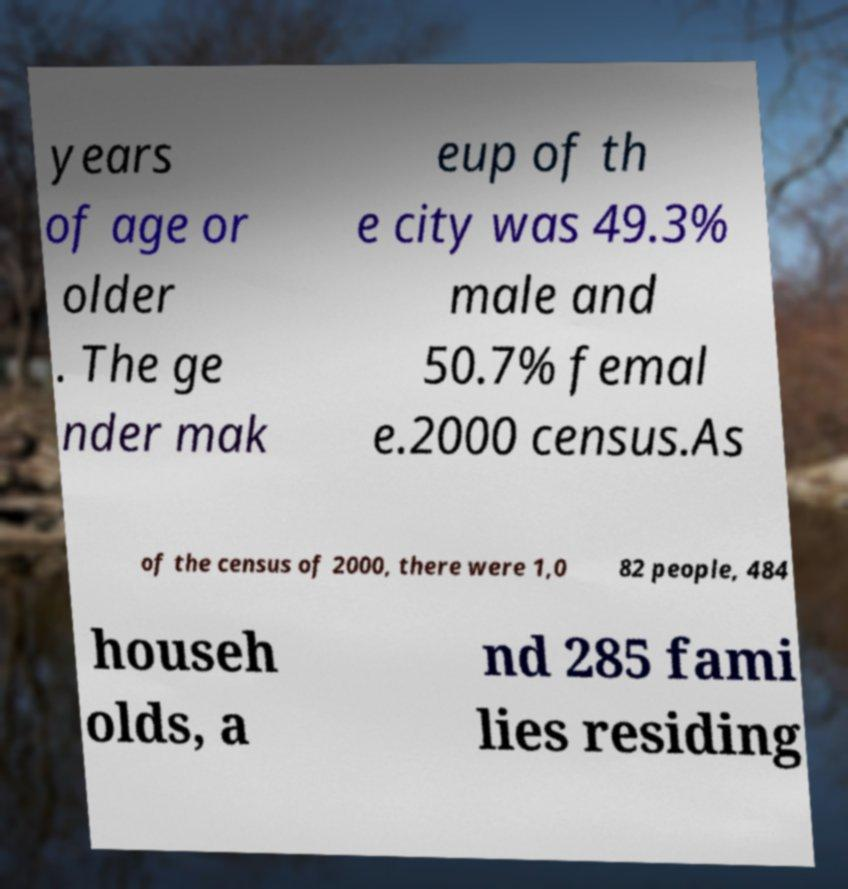Please identify and transcribe the text found in this image. years of age or older . The ge nder mak eup of th e city was 49.3% male and 50.7% femal e.2000 census.As of the census of 2000, there were 1,0 82 people, 484 househ olds, a nd 285 fami lies residing 